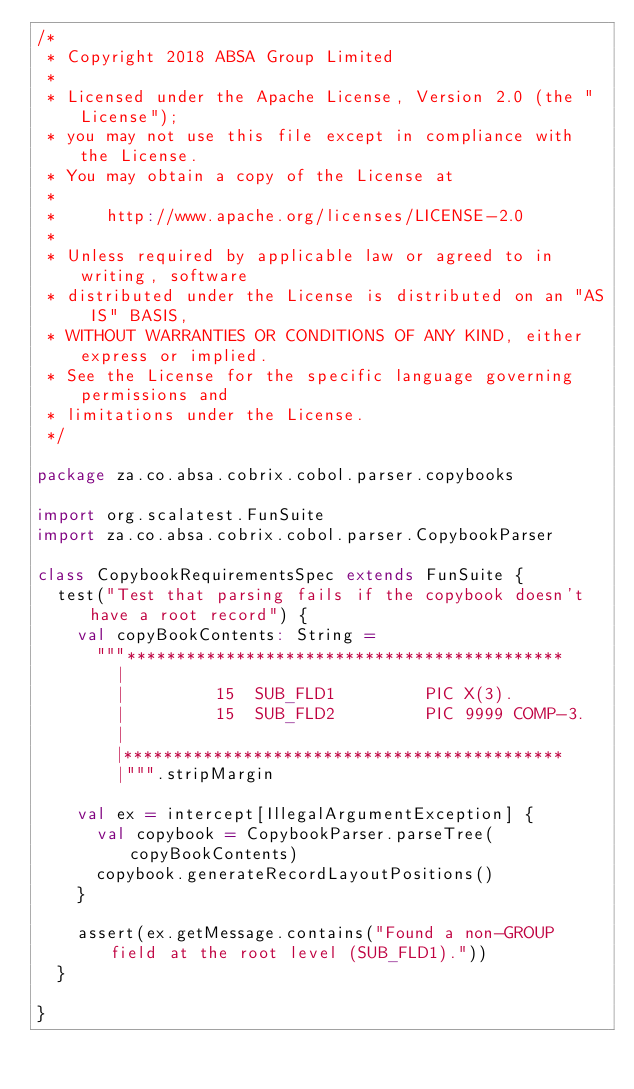Convert code to text. <code><loc_0><loc_0><loc_500><loc_500><_Scala_>/*
 * Copyright 2018 ABSA Group Limited
 *
 * Licensed under the Apache License, Version 2.0 (the "License");
 * you may not use this file except in compliance with the License.
 * You may obtain a copy of the License at
 *
 *     http://www.apache.org/licenses/LICENSE-2.0
 *
 * Unless required by applicable law or agreed to in writing, software
 * distributed under the License is distributed on an "AS IS" BASIS,
 * WITHOUT WARRANTIES OR CONDITIONS OF ANY KIND, either express or implied.
 * See the License for the specific language governing permissions and
 * limitations under the License.
 */

package za.co.absa.cobrix.cobol.parser.copybooks

import org.scalatest.FunSuite
import za.co.absa.cobrix.cobol.parser.CopybookParser

class CopybookRequirementsSpec extends FunSuite {
  test("Test that parsing fails if the copybook doesn't have a root record") {
    val copyBookContents: String =
      """********************************************
        |
        |         15  SUB_FLD1         PIC X(3).
        |         15  SUB_FLD2         PIC 9999 COMP-3.
        |
        |********************************************
        |""".stripMargin

    val ex = intercept[IllegalArgumentException] {
      val copybook = CopybookParser.parseTree(copyBookContents)
      copybook.generateRecordLayoutPositions()
    }

    assert(ex.getMessage.contains("Found a non-GROUP field at the root level (SUB_FLD1)."))
  }

}
</code> 